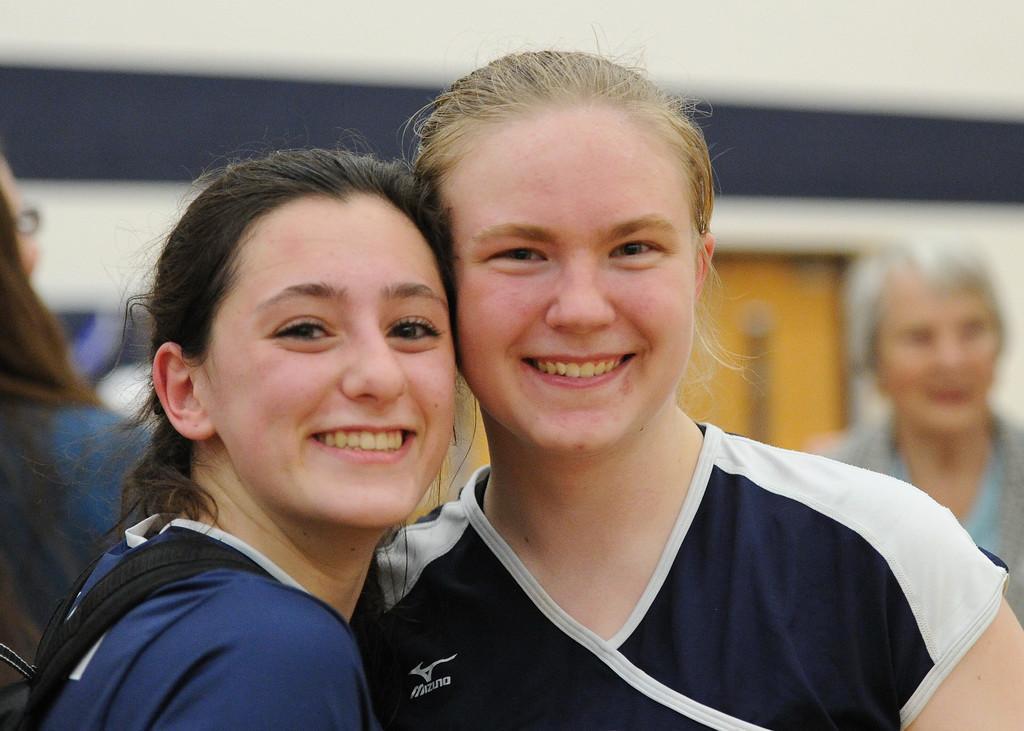In one or two sentences, can you explain what this image depicts? In the foreground we can see two women. In the background it is not clear yet we can see people and door. 